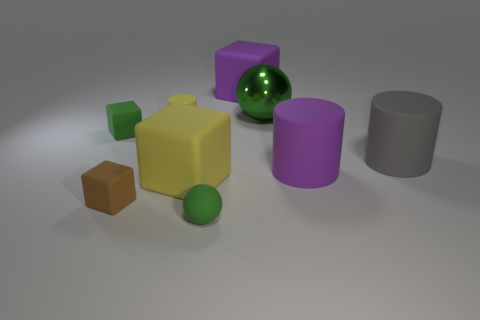Does the small brown object have the same shape as the large yellow rubber thing?
Provide a succinct answer. Yes. Is there any other thing that has the same material as the large green sphere?
Provide a succinct answer. No. What is the size of the rubber sphere?
Give a very brief answer. Small. There is a rubber object that is both behind the tiny green block and to the left of the small green matte ball; what color is it?
Make the answer very short. Yellow. Is the number of tiny green blocks greater than the number of large green metal cylinders?
Ensure brevity in your answer.  Yes. What number of things are either green spheres or big things that are in front of the purple rubber cylinder?
Provide a short and direct response. 3. Do the brown block and the green matte cube have the same size?
Provide a short and direct response. Yes. There is a tiny green rubber ball; are there any cylinders right of it?
Offer a terse response. Yes. There is a rubber cylinder that is both to the right of the rubber ball and to the left of the big gray rubber cylinder; what size is it?
Ensure brevity in your answer.  Large. How many things are either gray blocks or green rubber objects?
Your response must be concise. 2. 